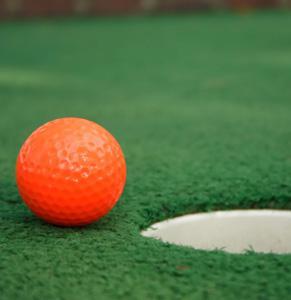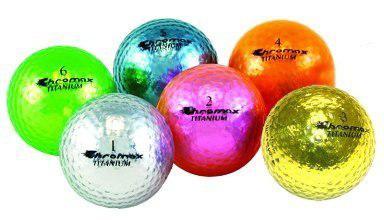The first image is the image on the left, the second image is the image on the right. For the images displayed, is the sentence "There is a ball near the hole in at least one of the images." factually correct? Answer yes or no. Yes. The first image is the image on the left, the second image is the image on the right. Considering the images on both sides, is "An image shows one golf ball next to a hole that does not have a pole in it." valid? Answer yes or no. Yes. 